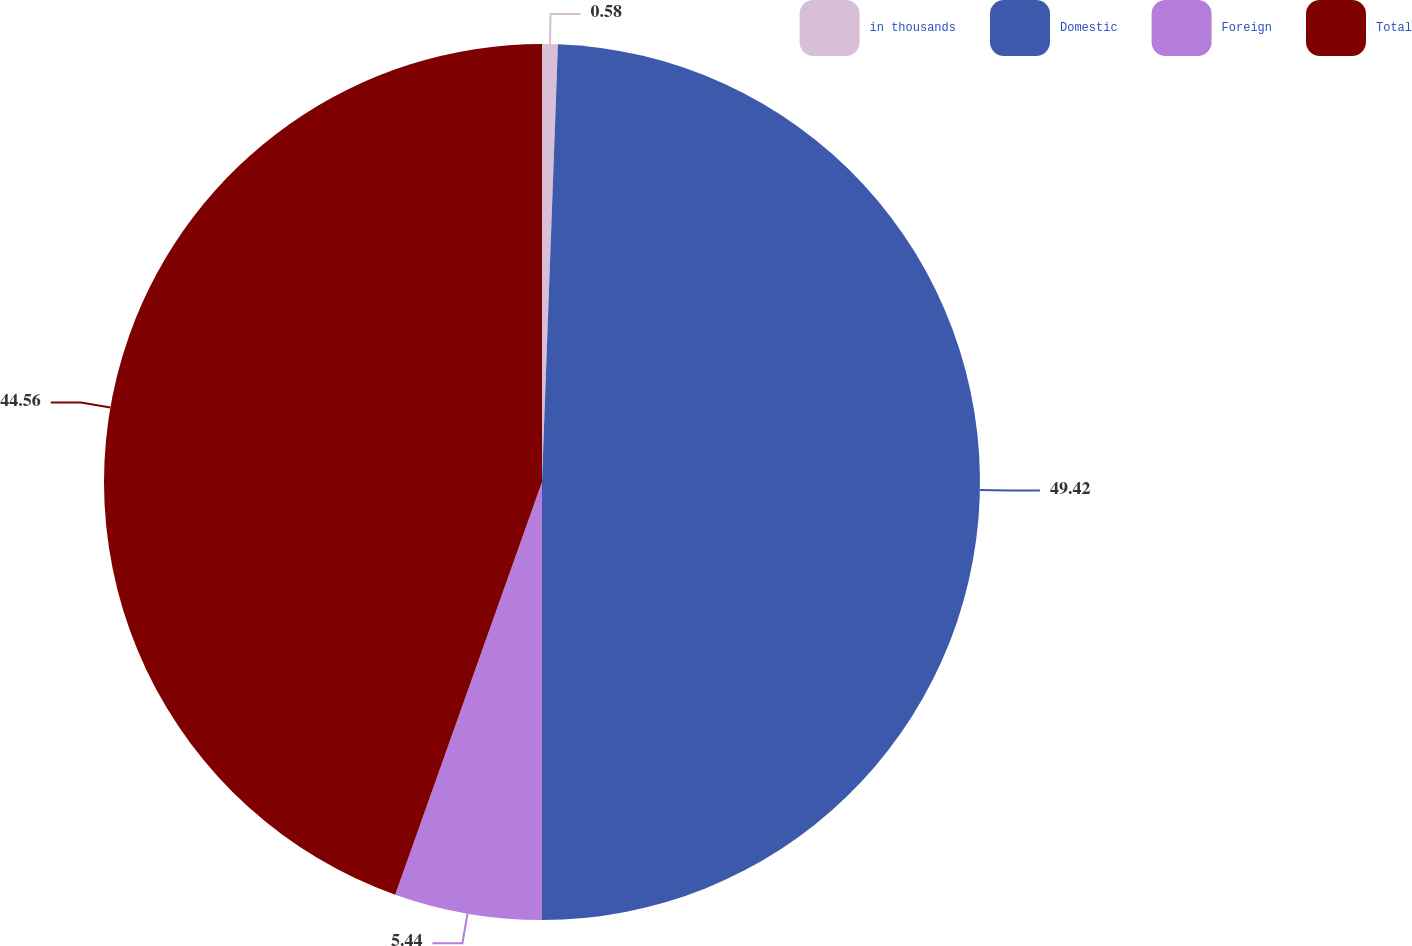Convert chart. <chart><loc_0><loc_0><loc_500><loc_500><pie_chart><fcel>in thousands<fcel>Domestic<fcel>Foreign<fcel>Total<nl><fcel>0.58%<fcel>49.42%<fcel>5.44%<fcel>44.56%<nl></chart> 